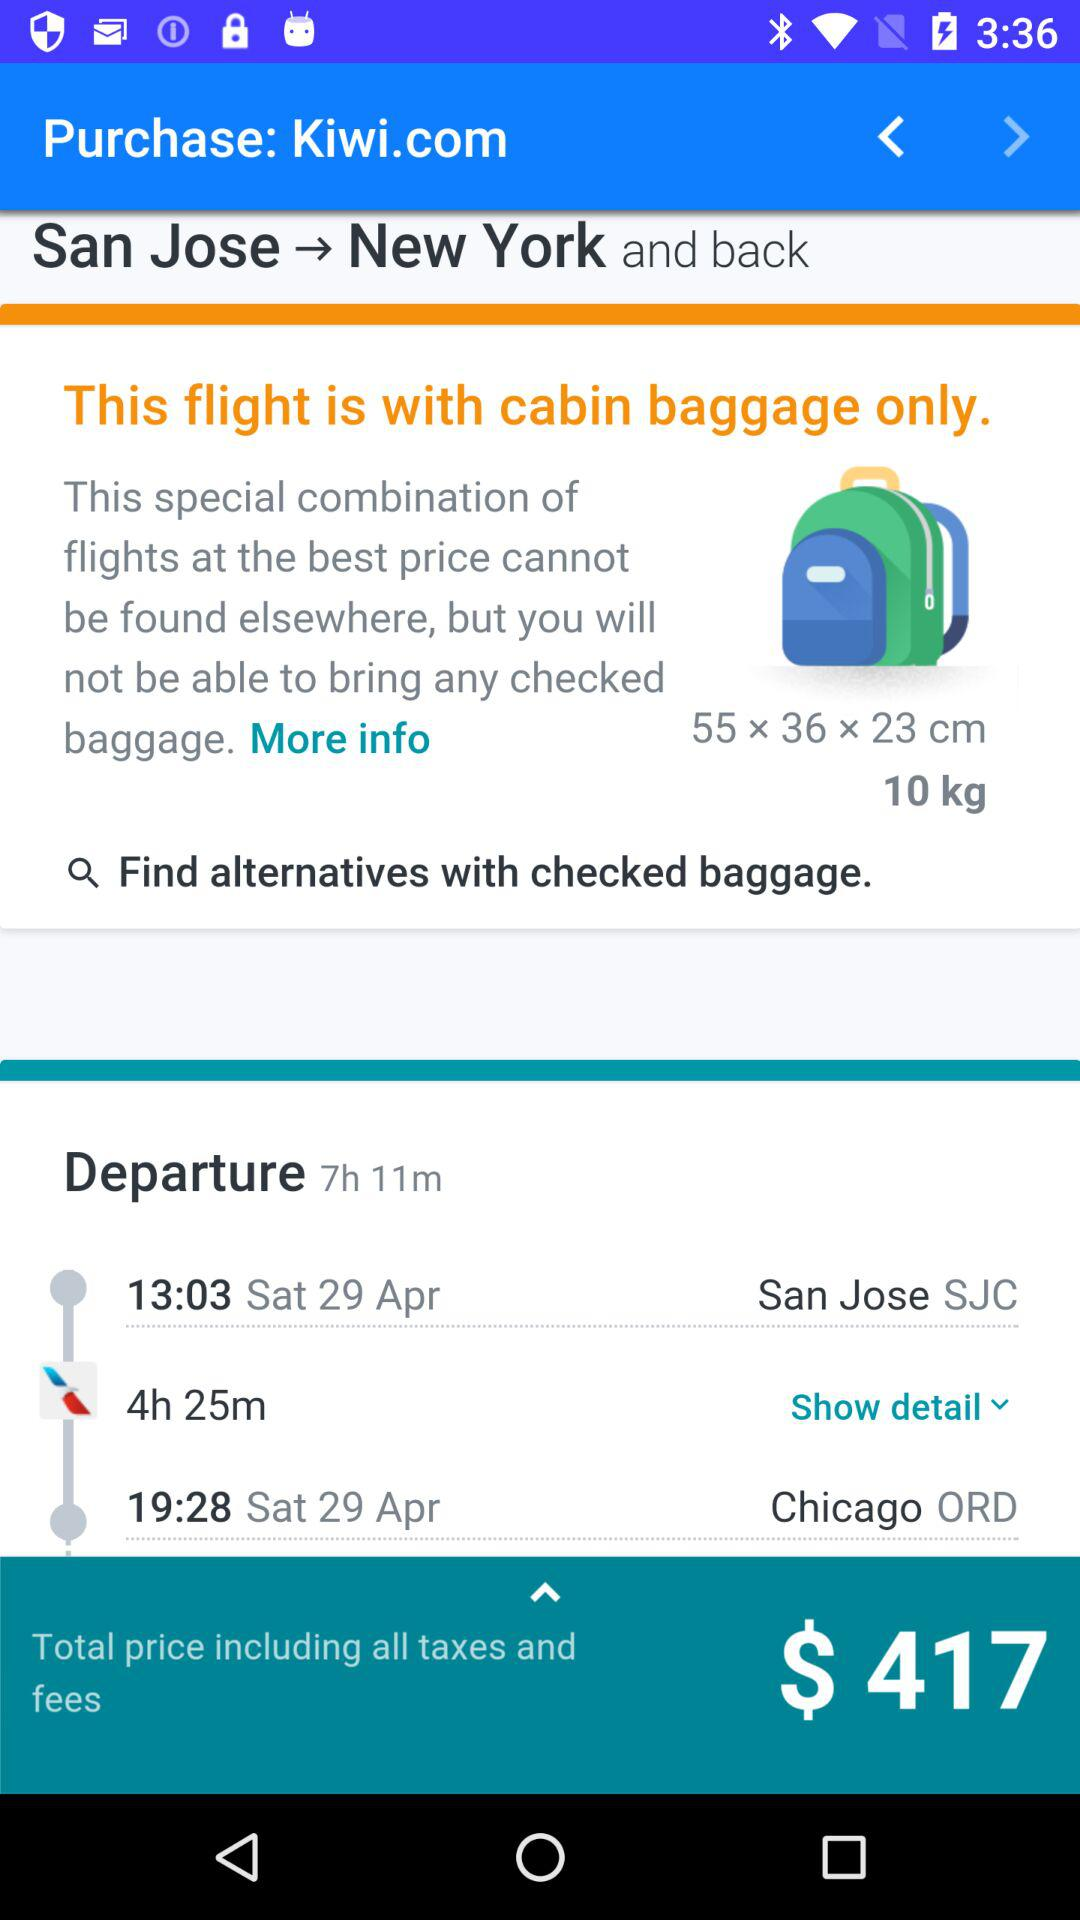What are the dimensions of baggage? The dimensions of the baggage is 55 x 36 x 23 cm. 